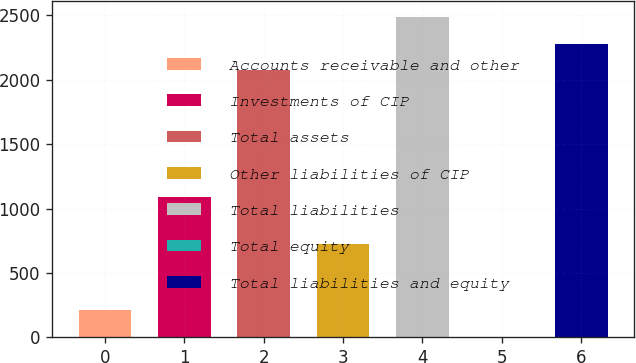Convert chart. <chart><loc_0><loc_0><loc_500><loc_500><bar_chart><fcel>Accounts receivable and other<fcel>Investments of CIP<fcel>Total assets<fcel>Other liabilities of CIP<fcel>Total liabilities<fcel>Total equity<fcel>Total liabilities and equity<nl><fcel>209.77<fcel>1091.9<fcel>2072.7<fcel>728.7<fcel>2487.24<fcel>2.5<fcel>2279.97<nl></chart> 